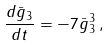<formula> <loc_0><loc_0><loc_500><loc_500>\frac { d \bar { g } _ { 3 } } { d t } = - 7 \bar { g } ^ { 3 } _ { 3 } \, ,</formula> 